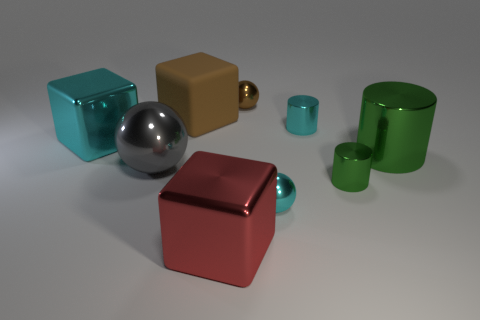There is a large thing that is to the right of the tiny brown thing; is it the same shape as the big red metal thing?
Provide a short and direct response. No. What number of objects are either shiny blocks on the left side of the gray ball or brown matte blocks?
Your answer should be very brief. 2. Is there a green metallic thing of the same shape as the large cyan metal object?
Your response must be concise. No. What shape is the cyan object that is the same size as the cyan cylinder?
Provide a short and direct response. Sphere. What is the shape of the brown thing that is right of the large block that is behind the big metallic cube that is to the left of the large red metal object?
Your answer should be very brief. Sphere. There is a big matte object; is its shape the same as the large object that is on the right side of the big red object?
Provide a short and direct response. No. What number of tiny objects are cyan rubber balls or gray metal balls?
Ensure brevity in your answer.  0. Is there another metallic sphere that has the same size as the cyan sphere?
Your response must be concise. Yes. The small metallic sphere that is in front of the cube that is behind the block that is to the left of the matte block is what color?
Your response must be concise. Cyan. Does the small green cylinder have the same material as the large block that is to the left of the large gray object?
Your response must be concise. Yes. 